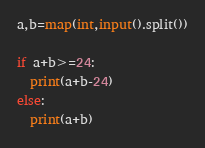Convert code to text. <code><loc_0><loc_0><loc_500><loc_500><_Python_>a,b=map(int,input().split())

if a+b>=24:
  print(a+b-24)
else:
  print(a+b)</code> 